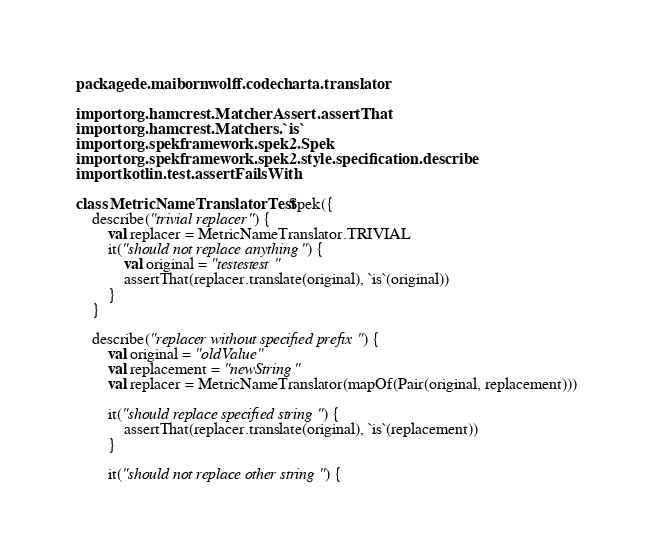<code> <loc_0><loc_0><loc_500><loc_500><_Kotlin_>package de.maibornwolff.codecharta.translator

import org.hamcrest.MatcherAssert.assertThat
import org.hamcrest.Matchers.`is`
import org.spekframework.spek2.Spek
import org.spekframework.spek2.style.specification.describe
import kotlin.test.assertFailsWith

class MetricNameTranslatorTest: Spek({
    describe("trivial replacer") {
        val replacer = MetricNameTranslator.TRIVIAL
        it("should not replace anything") {
            val original = "testestest"
            assertThat(replacer.translate(original), `is`(original))
        }
    }

    describe("replacer without specified prefix") {
        val original = "oldValue"
        val replacement = "newString"
        val replacer = MetricNameTranslator(mapOf(Pair(original, replacement)))

        it("should replace specified string") {
            assertThat(replacer.translate(original), `is`(replacement))
        }

        it("should not replace other string") {</code> 